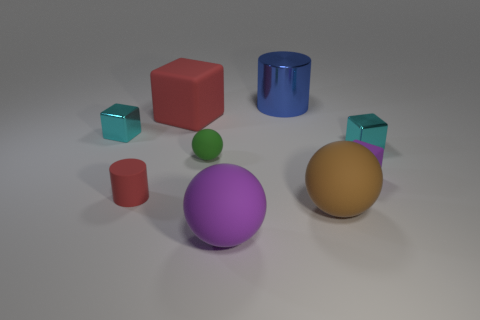Subtract 1 blocks. How many blocks are left? 3 Add 1 purple cubes. How many objects exist? 10 Subtract all cubes. How many objects are left? 5 Subtract all big blue rubber balls. Subtract all tiny cyan metallic cubes. How many objects are left? 7 Add 6 small cyan things. How many small cyan things are left? 8 Add 4 purple matte blocks. How many purple matte blocks exist? 5 Subtract 0 yellow spheres. How many objects are left? 9 